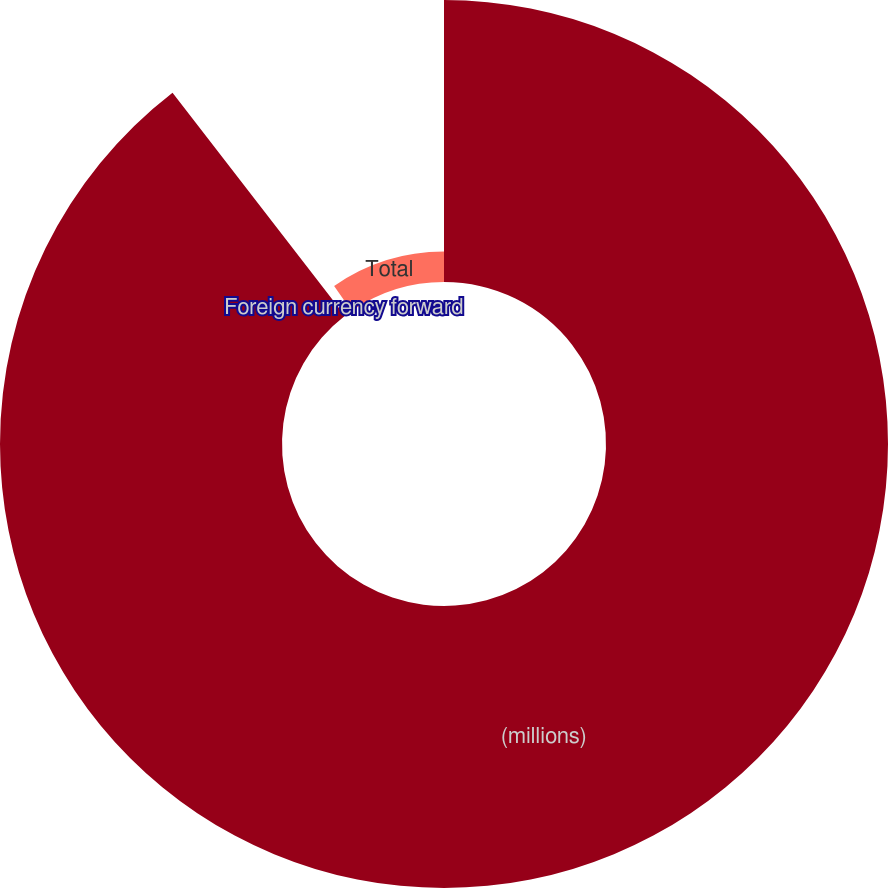Convert chart. <chart><loc_0><loc_0><loc_500><loc_500><pie_chart><fcel>(millions)<fcel>Foreign currency forward<fcel>Total<nl><fcel>89.53%<fcel>0.8%<fcel>9.67%<nl></chart> 